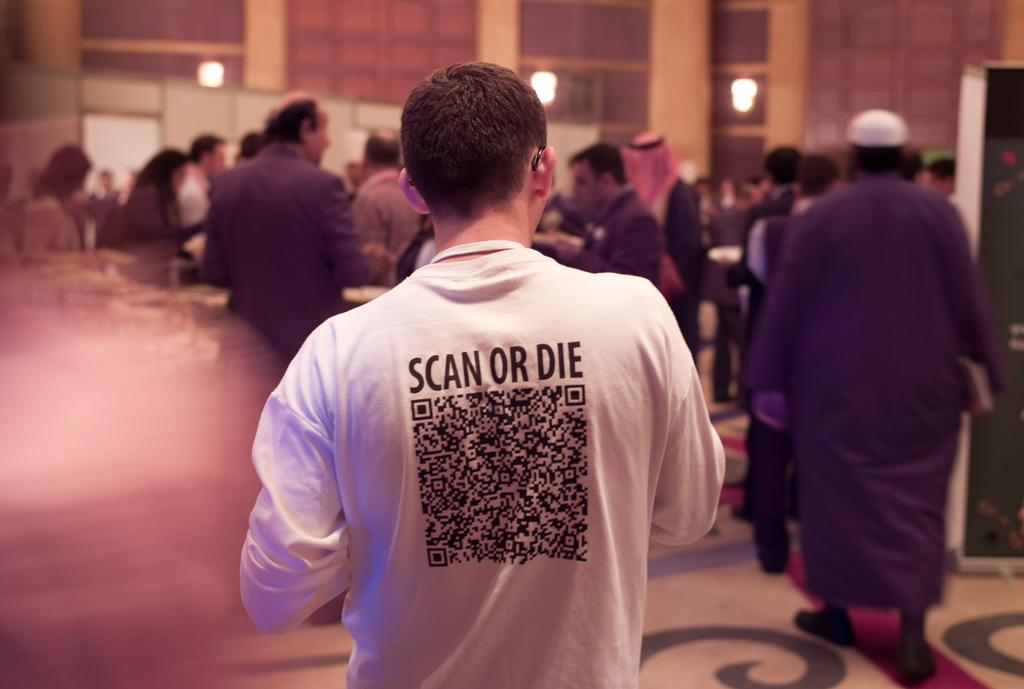What can be seen in the image involving multiple individuals? There are groups of people standing in the image. What are some of the people holding in their hands? Some people are holding objects in their hands. What can be seen in the background of the image? There are lamps and walls visible in the background of the image. What type of surface is visible beneath the people? The image shows a floor. What type of knot is being tied by the people in the image? There is no knot-tying activity depicted in the image. Can you tell me how many horses are pulling the carriage in the image? There is no carriage present in the image. 